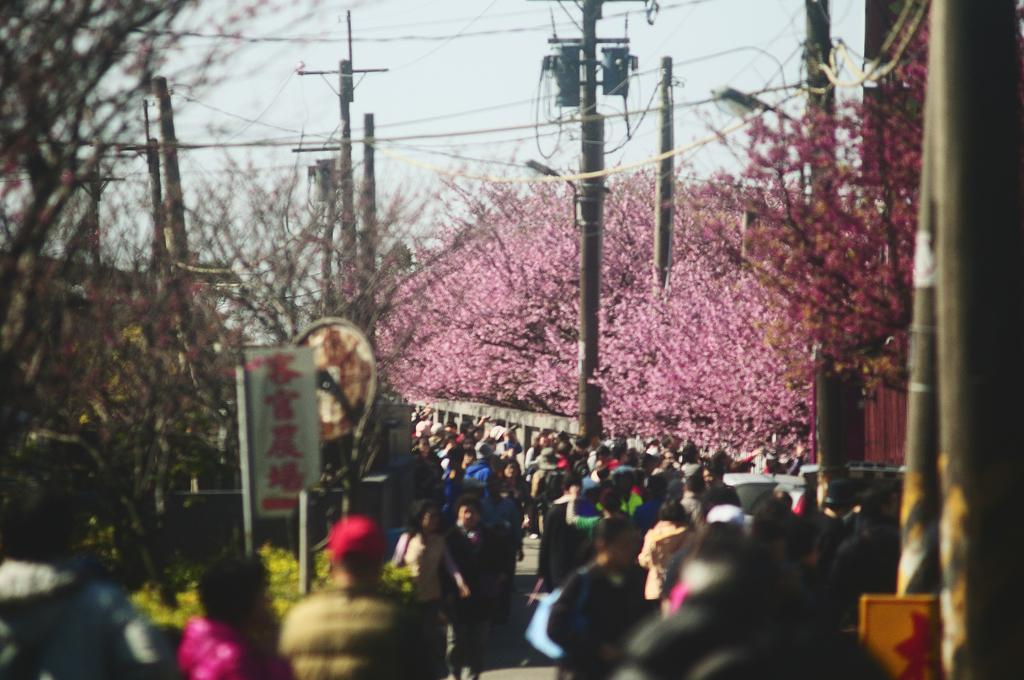What is happening on the road in the image? There is a group of people on the road in the image. What can be seen in the image besides the people? There are poles, trees, a banner, and some objects visible in the image. What is the purpose of the banner in the image? The purpose of the banner cannot be determined from the image alone. What is visible in the background of the image? The sky is visible in the background of the image. How does the soap help the garden in the image? There is no soap or garden present in the image. 